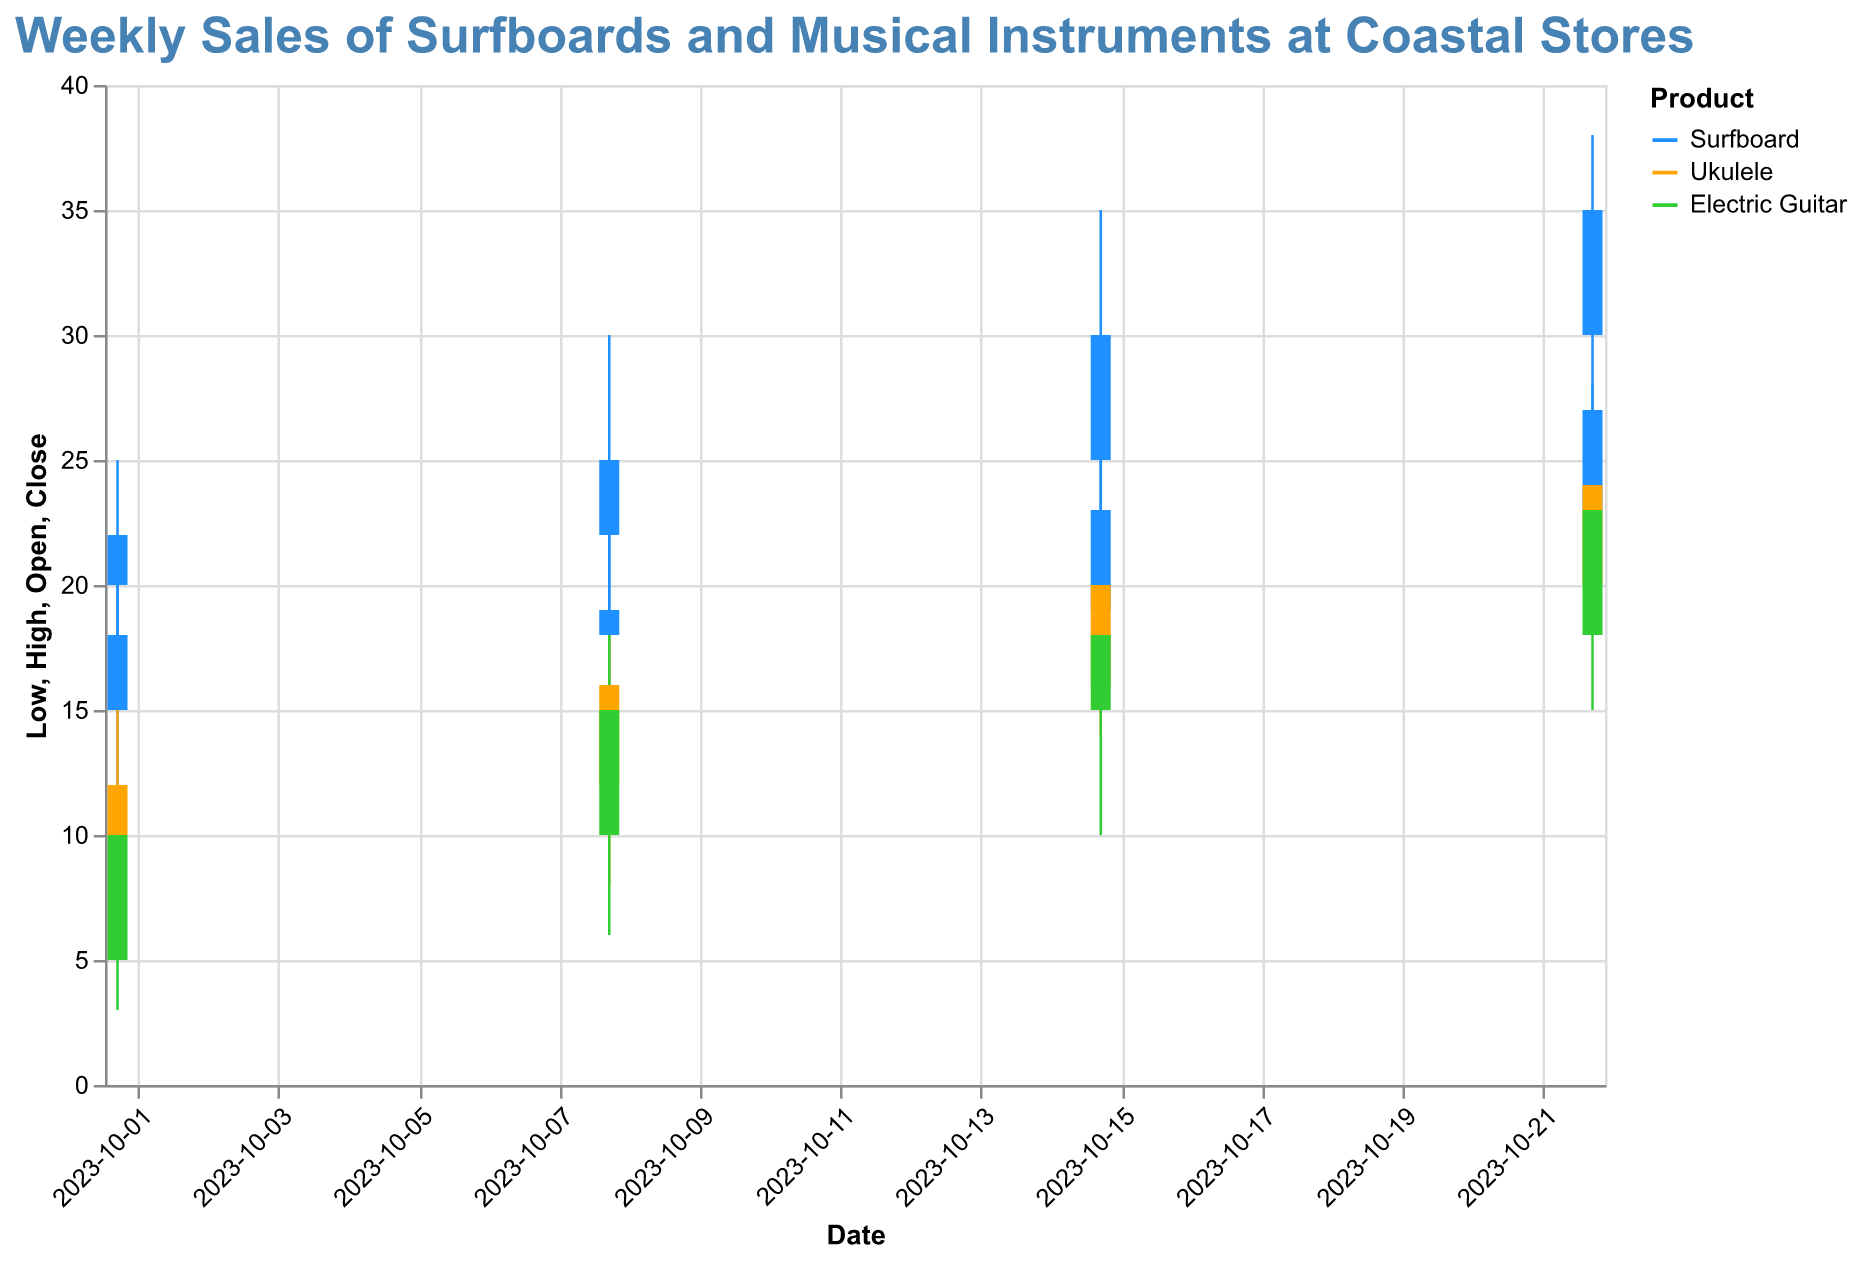What is the color used for the surfboard data? The surfboard data is color-coded with a specific shade that represents it across the entire plot. Look at the legend in the chart, which shows that the surfboard data is marked with the color blue.
Answer: Blue How many stores are tracked in the plot? The plot shows sales data from different stores, denoted by the "Store" field in the data. There are four stores listed: Surf Paradise, Music Haven, Wave Riders, and Ocean Tunes.
Answer: Four Which store had the highest closing sales for ukuleles on October 22, 2023? To find the highest closing sales for ukuleles on October 22, 2023, check the candlestick details for Music Haven. The closing sales for ukuleles from Music Haven on that date was 24, which is the highest.
Answer: Music Haven What is the difference in closing sales of surfboards between Surf Paradise and Wave Riders on October 15, 2023? On October 15, 2023, the closing sales for surfboards in Surf Paradise was 23, and for Wave Riders, it was 30. The difference can be calculated as 30 - 23.
Answer: 7 Which item saw the greatest increase in closing sales from October 1 to October 8 at Ocean Tunes? Look at the closing sales at Ocean Tunes for both dates. On October 1, the electric guitar had a closing of 10, and on October 8, it closed at 15. The increase is 15 - 10 = 5.
Answer: Electric Guitar Identify the week in which Wave Riders had an opening sales value of 30 for surfboards? Check the values for the opening sales of surfboards at Wave Riders across the weeks. On October 22, 2023, the opening sales value for Wave Riders was 30.
Answer: October 22, 2023 Compare the highest sales price for electric guitars at Ocean Tunes during the first and last weeks of October. The first week (October 1) has a high of 12 for electric guitars, and the last week (October 22) has a high of 25. Compare these values to see that the highest price increased from 12 to 25.
Answer: Increased from 12 to 25 What is the median closing price for surfboards at Surf Paradise across all weeks? Use the closing prices of Surfboards at Surf Paradise: 18, 19, 23, 27. Arrange these values in order and find the middle value(s). Since there are 4 values, the median is the average of the two middle numbers (19 + 23) / 2.
Answer: 21 Which week had the lowest high price for ukuleles at Music Haven? Check the high prices for ukuleles each week at Music Haven. The high prices are: 15 (Oct-1), 18 (Oct-8), 22 (Oct-15), and 26 (Oct-22). The lowest high is on October 1, at 15.
Answer: October 1, 2023 